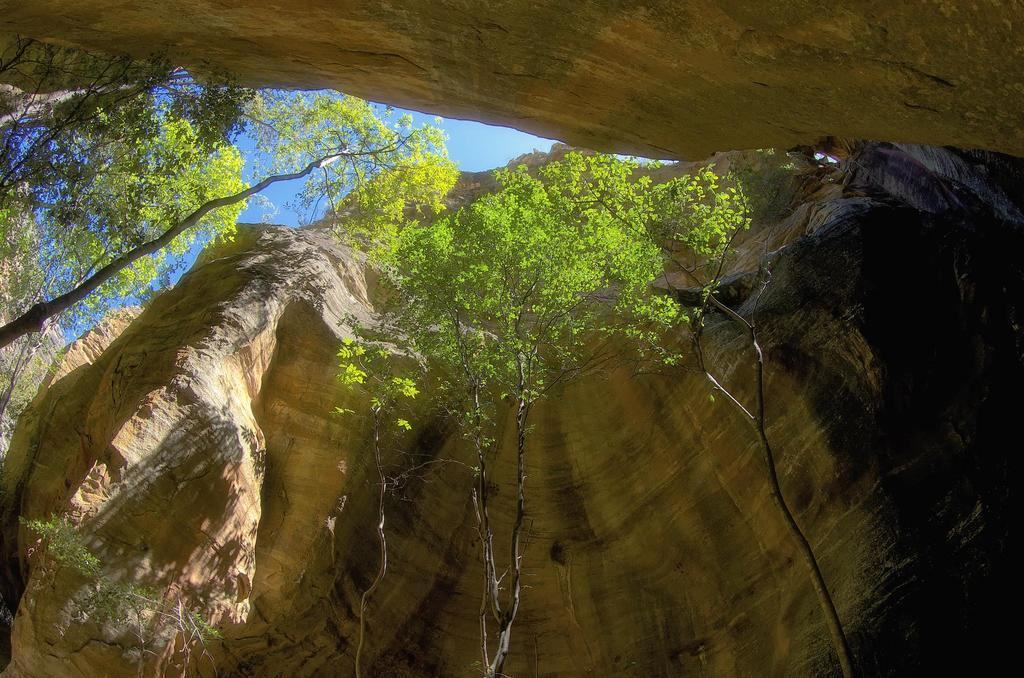What type of natural landscape can be seen in the image? There is a view of trees and mountain caves in the image. From where is the viewpoint of the image? The view is from the bottom. What color is the sky in the image? The sky is blue at the top of the image. Can you see any stars in the image? There are no stars visible in the image. 